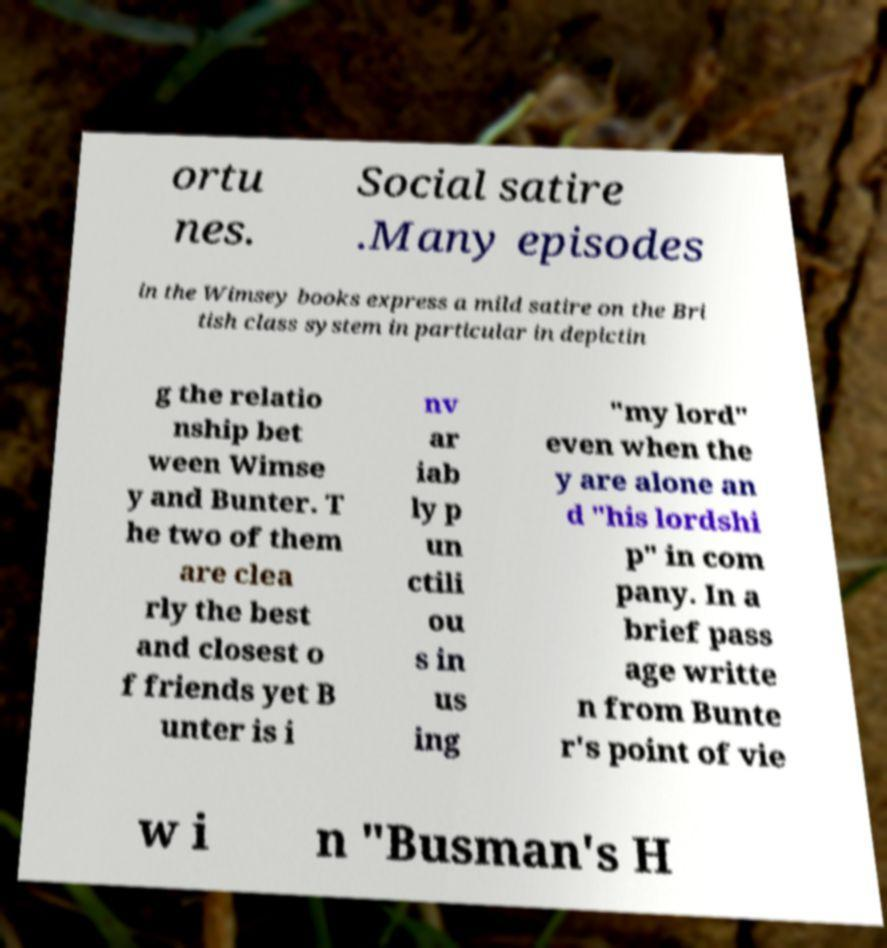Can you accurately transcribe the text from the provided image for me? ortu nes. Social satire .Many episodes in the Wimsey books express a mild satire on the Bri tish class system in particular in depictin g the relatio nship bet ween Wimse y and Bunter. T he two of them are clea rly the best and closest o f friends yet B unter is i nv ar iab ly p un ctili ou s in us ing "my lord" even when the y are alone an d "his lordshi p" in com pany. In a brief pass age writte n from Bunte r's point of vie w i n "Busman's H 